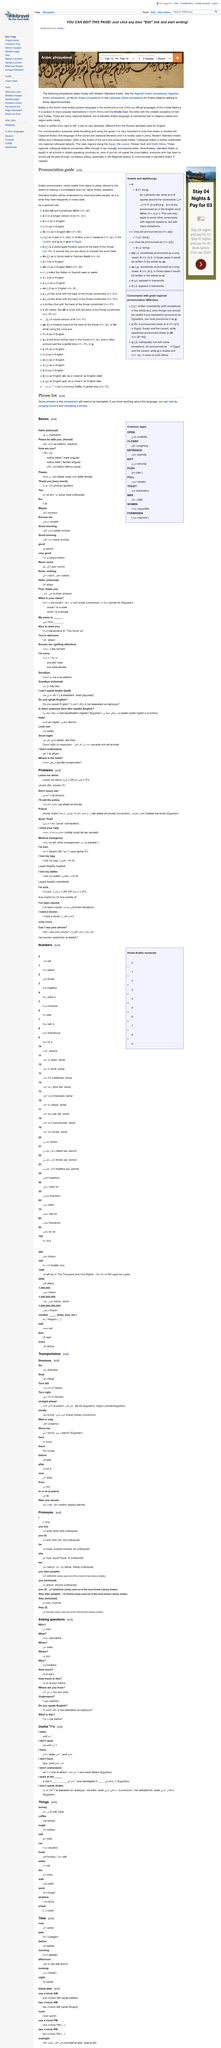Point out several critical features in this image. In the illustration, there are two guests. The check-in date in the illustration is February 12th. The article is discussing Arabic as the language being discussed. 